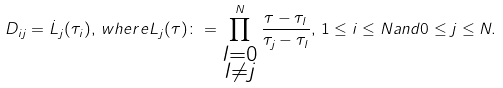Convert formula to latex. <formula><loc_0><loc_0><loc_500><loc_500>D _ { i j } = \dot { L } _ { j } ( \tau _ { i } ) , \, w h e r e L _ { j } ( \tau ) \colon = \prod ^ { N } _ { \substack { l = 0 \\ l \neq j } } \frac { \tau - \tau _ { l } } { \tau _ { j } - \tau _ { l } } , \, 1 \leq i \leq N a n d 0 \leq j \leq N .</formula> 